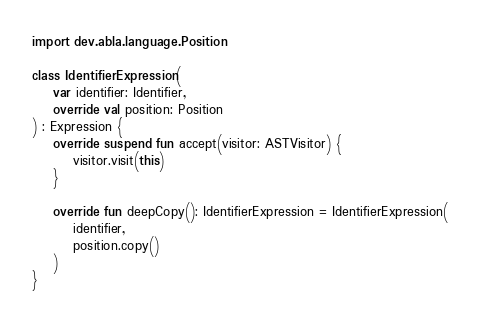Convert code to text. <code><loc_0><loc_0><loc_500><loc_500><_Kotlin_>import dev.abla.language.Position

class IdentifierExpression(
    var identifier: Identifier,
    override val position: Position
) : Expression {
    override suspend fun accept(visitor: ASTVisitor) {
        visitor.visit(this)
    }

    override fun deepCopy(): IdentifierExpression = IdentifierExpression(
        identifier,
        position.copy()
    )
}</code> 